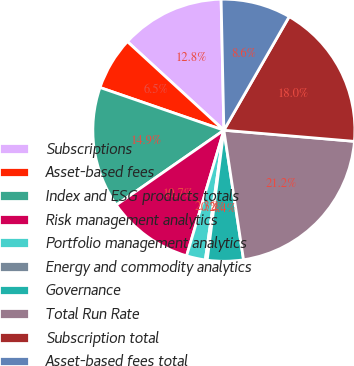Convert chart to OTSL. <chart><loc_0><loc_0><loc_500><loc_500><pie_chart><fcel>Subscriptions<fcel>Asset-based fees<fcel>Index and ESG products totals<fcel>Risk management analytics<fcel>Portfolio management analytics<fcel>Energy and commodity analytics<fcel>Governance<fcel>Total Run Rate<fcel>Subscription total<fcel>Asset-based fees total<nl><fcel>12.84%<fcel>6.54%<fcel>14.95%<fcel>10.74%<fcel>2.33%<fcel>0.23%<fcel>4.43%<fcel>21.25%<fcel>18.05%<fcel>8.64%<nl></chart> 